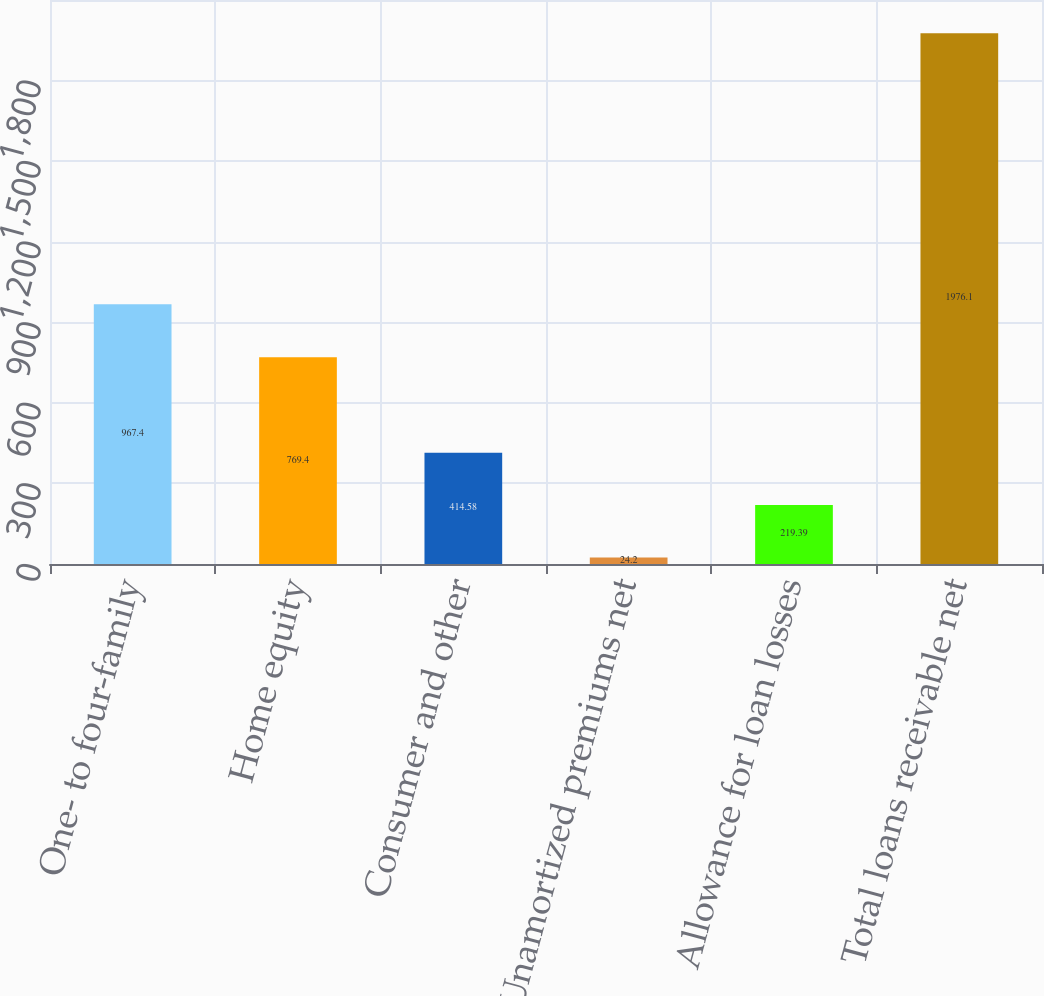Convert chart to OTSL. <chart><loc_0><loc_0><loc_500><loc_500><bar_chart><fcel>One- to four-family<fcel>Home equity<fcel>Consumer and other<fcel>Unamortized premiums net<fcel>Allowance for loan losses<fcel>Total loans receivable net<nl><fcel>967.4<fcel>769.4<fcel>414.58<fcel>24.2<fcel>219.39<fcel>1976.1<nl></chart> 